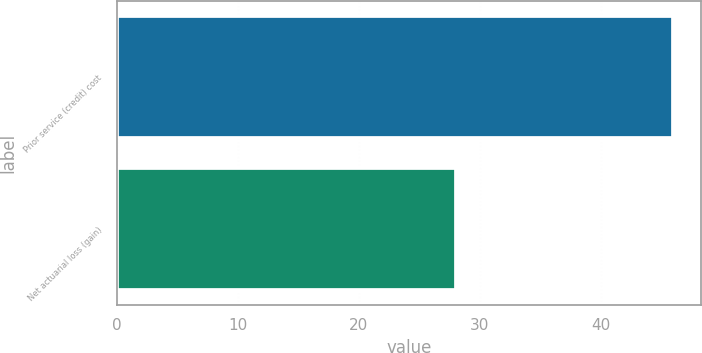<chart> <loc_0><loc_0><loc_500><loc_500><bar_chart><fcel>Prior service (credit) cost<fcel>Net actuarial loss (gain)<nl><fcel>46<fcel>28<nl></chart> 